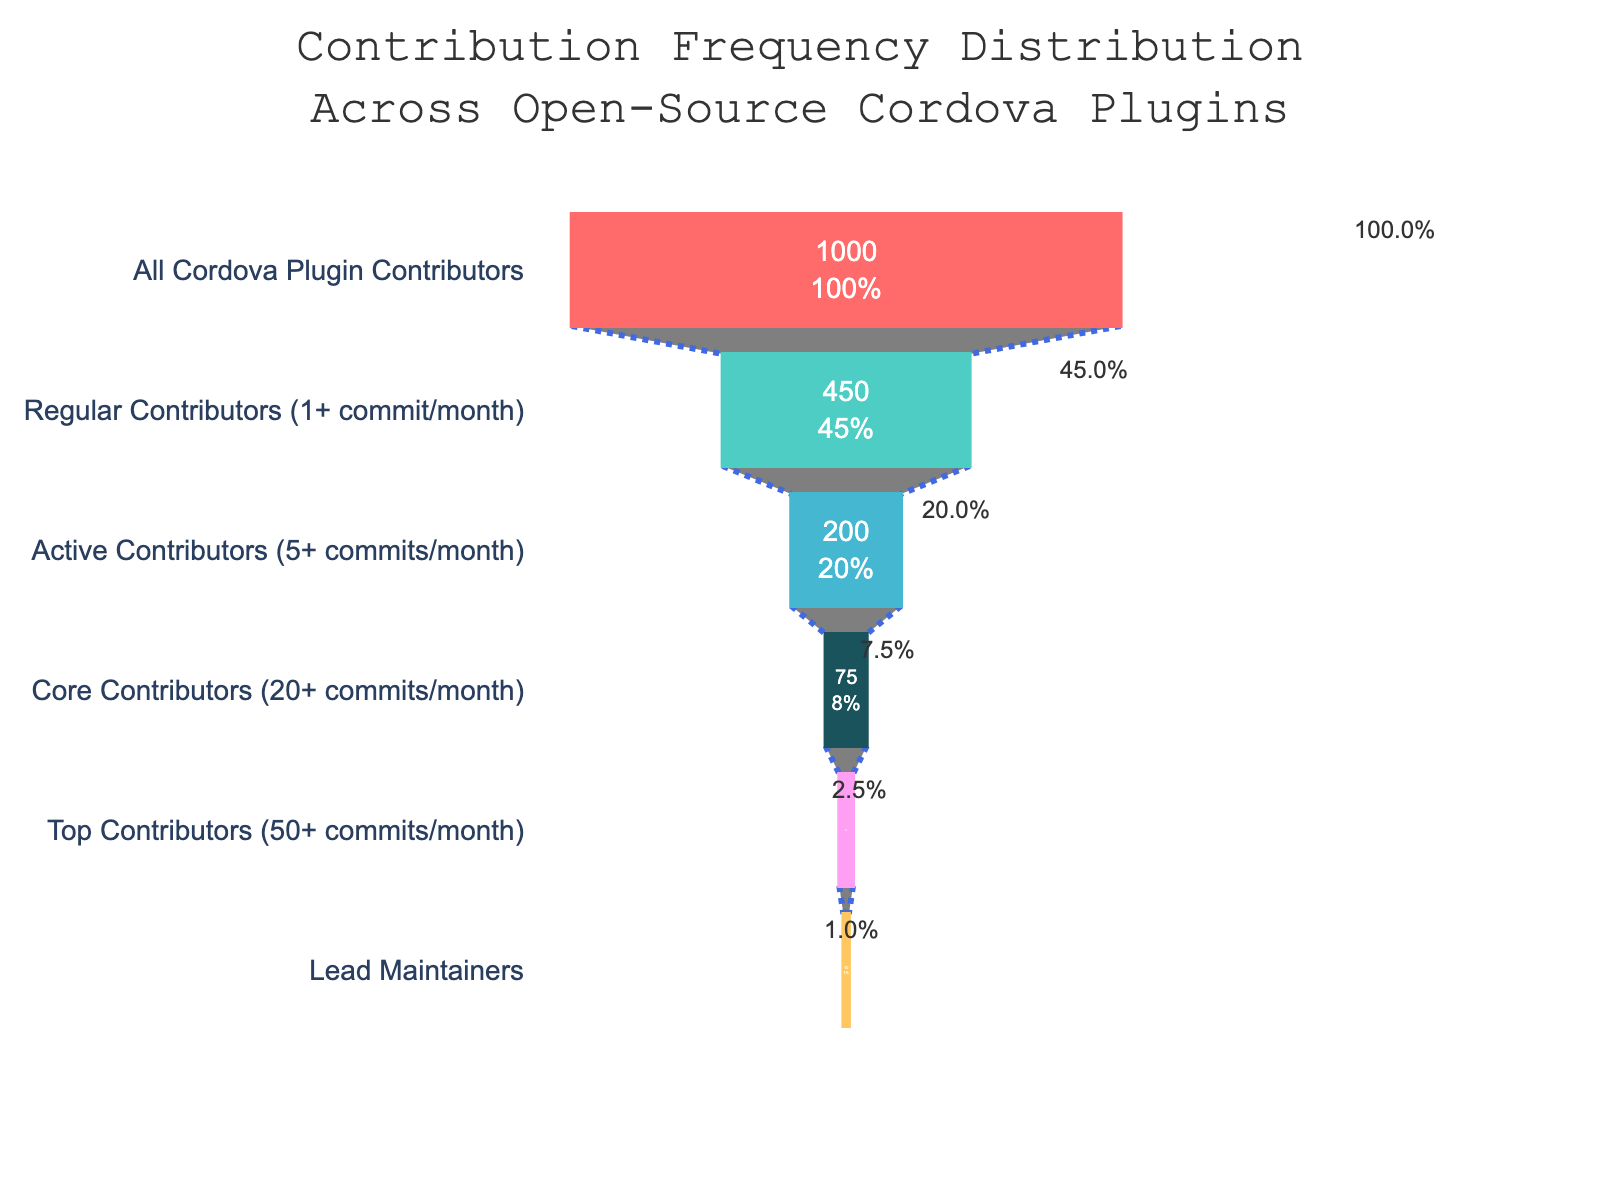What's the total number of contributors who make at least one commit per month? To find this, look at the stage "Regular Contributors (1+ commit/month)" which lists 450 contributors.
Answer: 450 What is the greatest drop in the number of contributors between consecutive stages? Compare the differences between consecutive stages. The largest difference is from "Regular Contributors (1+ commit/month)" to "Active Contributors (5+ commits/month)", which is 450 - 200 = 250.
Answer: 250 Which stage has the smallest number of contributors? Look for the stage with the lowest contributors value. The "Lead Maintainers" stage has the smallest number with 10 contributors.
Answer: Lead Maintainers What percentage of all Cordova plugin contributors are "Top Contributors"? The "Top Contributors" stage indicates this information directly with a value of 2.5%.
Answer: 2.5% What's the ratio of "Core Contributors" to "Lead Maintainers"? Divide the number of "Core Contributors" (75) by the number of "Lead Maintainers" (10). The ratio is 75 / 10 = 7.5.
Answer: 7.5 By what factor do "All Cordova Plugin Contributors" exceed "Lead Maintainers"? Divide the number of "All Cordova Plugin Contributors" (1000) by the number of "Lead Maintainers" (10). The factor is 1000 / 10 = 100.
Answer: 100 How does the number of "Active Contributors" compare with the number of "Core Contributors"? Compare the values directly. There are 200 "Active Contributors" and 75 "Core Contributors". 200 is greater than 75.
Answer: Greater What's the sum of "Top Contributors" and "Core Contributors"? Add the contributors from both stages: 25 (Top Contributors) + 75 (Core Contributors) = 100.
Answer: 100 What is the funnel chart title? The title of the chart is displayed at the top: "Contribution Frequency Distribution Across Open-Source Cordova Plugins".
Answer: Contribution Frequency Distribution Across Open-Source Cordova Plugins What color is used for the "Regular Contributors" segment? The segment for "Regular Contributors" is colored in a turquoise green shade.
Answer: Turquoise Green 